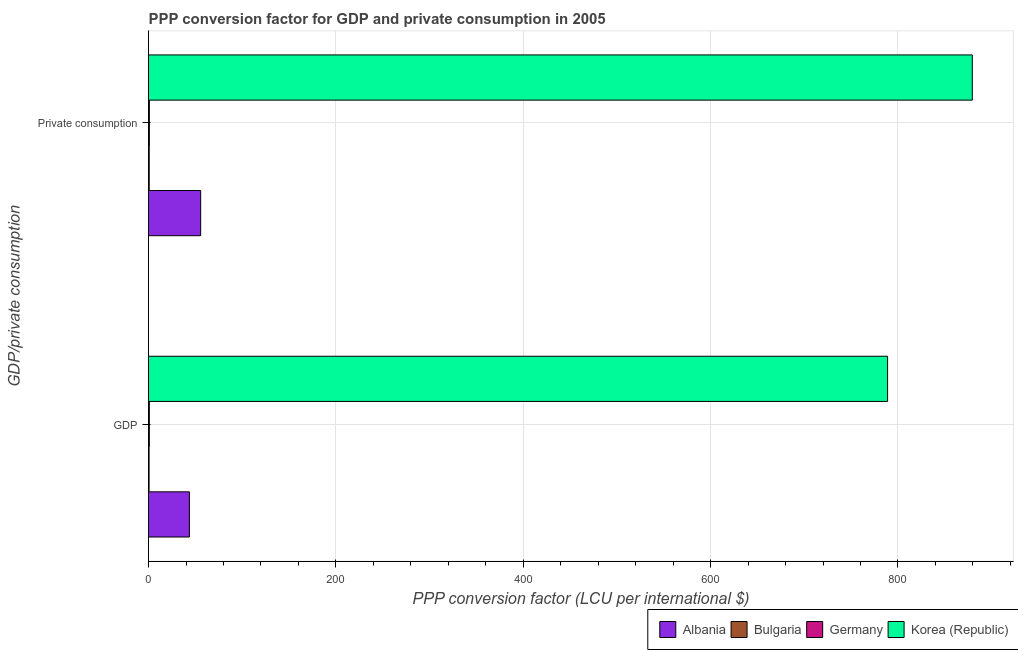How many different coloured bars are there?
Keep it short and to the point. 4. How many bars are there on the 1st tick from the bottom?
Your answer should be compact. 4. What is the label of the 1st group of bars from the top?
Your response must be concise.  Private consumption. What is the ppp conversion factor for private consumption in Germany?
Your response must be concise. 0.9. Across all countries, what is the maximum ppp conversion factor for private consumption?
Your response must be concise. 879.37. Across all countries, what is the minimum ppp conversion factor for private consumption?
Provide a succinct answer. 0.73. In which country was the ppp conversion factor for private consumption maximum?
Give a very brief answer. Korea (Republic). In which country was the ppp conversion factor for private consumption minimum?
Your response must be concise. Bulgaria. What is the total ppp conversion factor for private consumption in the graph?
Provide a succinct answer. 936.65. What is the difference between the ppp conversion factor for private consumption in Korea (Republic) and that in Germany?
Your response must be concise. 878.47. What is the difference between the ppp conversion factor for private consumption in Germany and the ppp conversion factor for gdp in Bulgaria?
Offer a very short reply. 0.3. What is the average ppp conversion factor for private consumption per country?
Offer a terse response. 234.16. What is the difference between the ppp conversion factor for private consumption and ppp conversion factor for gdp in Albania?
Your response must be concise. 12.01. In how many countries, is the ppp conversion factor for private consumption greater than 880 LCU?
Your response must be concise. 0. What is the ratio of the ppp conversion factor for private consumption in Korea (Republic) to that in Bulgaria?
Your answer should be very brief. 1197.36. Is the ppp conversion factor for gdp in Albania less than that in Korea (Republic)?
Offer a terse response. Yes. What does the 2nd bar from the bottom in GDP represents?
Offer a very short reply. Bulgaria. Are all the bars in the graph horizontal?
Make the answer very short. Yes. How many countries are there in the graph?
Your response must be concise. 4. Are the values on the major ticks of X-axis written in scientific E-notation?
Give a very brief answer. No. Does the graph contain any zero values?
Offer a terse response. No. Where does the legend appear in the graph?
Ensure brevity in your answer.  Bottom right. How many legend labels are there?
Make the answer very short. 4. How are the legend labels stacked?
Offer a terse response. Horizontal. What is the title of the graph?
Offer a very short reply. PPP conversion factor for GDP and private consumption in 2005. Does "Singapore" appear as one of the legend labels in the graph?
Offer a terse response. No. What is the label or title of the X-axis?
Provide a succinct answer. PPP conversion factor (LCU per international $). What is the label or title of the Y-axis?
Your response must be concise. GDP/private consumption. What is the PPP conversion factor (LCU per international $) of Albania in GDP?
Provide a succinct answer. 43.64. What is the PPP conversion factor (LCU per international $) of Bulgaria in GDP?
Offer a very short reply. 0.6. What is the PPP conversion factor (LCU per international $) in Germany in GDP?
Provide a succinct answer. 0.87. What is the PPP conversion factor (LCU per international $) of Korea (Republic) in GDP?
Provide a short and direct response. 788.92. What is the PPP conversion factor (LCU per international $) of Albania in  Private consumption?
Ensure brevity in your answer.  55.65. What is the PPP conversion factor (LCU per international $) of Bulgaria in  Private consumption?
Offer a terse response. 0.73. What is the PPP conversion factor (LCU per international $) of Germany in  Private consumption?
Provide a succinct answer. 0.9. What is the PPP conversion factor (LCU per international $) in Korea (Republic) in  Private consumption?
Your response must be concise. 879.37. Across all GDP/private consumption, what is the maximum PPP conversion factor (LCU per international $) in Albania?
Give a very brief answer. 55.65. Across all GDP/private consumption, what is the maximum PPP conversion factor (LCU per international $) of Bulgaria?
Your response must be concise. 0.73. Across all GDP/private consumption, what is the maximum PPP conversion factor (LCU per international $) in Germany?
Provide a succinct answer. 0.9. Across all GDP/private consumption, what is the maximum PPP conversion factor (LCU per international $) of Korea (Republic)?
Provide a short and direct response. 879.37. Across all GDP/private consumption, what is the minimum PPP conversion factor (LCU per international $) in Albania?
Ensure brevity in your answer.  43.64. Across all GDP/private consumption, what is the minimum PPP conversion factor (LCU per international $) of Bulgaria?
Make the answer very short. 0.6. Across all GDP/private consumption, what is the minimum PPP conversion factor (LCU per international $) in Germany?
Ensure brevity in your answer.  0.87. Across all GDP/private consumption, what is the minimum PPP conversion factor (LCU per international $) of Korea (Republic)?
Make the answer very short. 788.92. What is the total PPP conversion factor (LCU per international $) of Albania in the graph?
Keep it short and to the point. 99.29. What is the total PPP conversion factor (LCU per international $) in Bulgaria in the graph?
Your answer should be compact. 1.33. What is the total PPP conversion factor (LCU per international $) in Germany in the graph?
Ensure brevity in your answer.  1.76. What is the total PPP conversion factor (LCU per international $) of Korea (Republic) in the graph?
Your response must be concise. 1668.29. What is the difference between the PPP conversion factor (LCU per international $) of Albania in GDP and that in  Private consumption?
Offer a terse response. -12.01. What is the difference between the PPP conversion factor (LCU per international $) in Bulgaria in GDP and that in  Private consumption?
Offer a very short reply. -0.14. What is the difference between the PPP conversion factor (LCU per international $) in Germany in GDP and that in  Private consumption?
Your response must be concise. -0.03. What is the difference between the PPP conversion factor (LCU per international $) of Korea (Republic) in GDP and that in  Private consumption?
Your response must be concise. -90.45. What is the difference between the PPP conversion factor (LCU per international $) of Albania in GDP and the PPP conversion factor (LCU per international $) of Bulgaria in  Private consumption?
Provide a succinct answer. 42.91. What is the difference between the PPP conversion factor (LCU per international $) in Albania in GDP and the PPP conversion factor (LCU per international $) in Germany in  Private consumption?
Ensure brevity in your answer.  42.74. What is the difference between the PPP conversion factor (LCU per international $) of Albania in GDP and the PPP conversion factor (LCU per international $) of Korea (Republic) in  Private consumption?
Give a very brief answer. -835.73. What is the difference between the PPP conversion factor (LCU per international $) in Bulgaria in GDP and the PPP conversion factor (LCU per international $) in Germany in  Private consumption?
Your response must be concise. -0.3. What is the difference between the PPP conversion factor (LCU per international $) in Bulgaria in GDP and the PPP conversion factor (LCU per international $) in Korea (Republic) in  Private consumption?
Your answer should be compact. -878.77. What is the difference between the PPP conversion factor (LCU per international $) of Germany in GDP and the PPP conversion factor (LCU per international $) of Korea (Republic) in  Private consumption?
Your response must be concise. -878.5. What is the average PPP conversion factor (LCU per international $) of Albania per GDP/private consumption?
Offer a terse response. 49.65. What is the average PPP conversion factor (LCU per international $) in Bulgaria per GDP/private consumption?
Give a very brief answer. 0.67. What is the average PPP conversion factor (LCU per international $) of Germany per GDP/private consumption?
Give a very brief answer. 0.88. What is the average PPP conversion factor (LCU per international $) in Korea (Republic) per GDP/private consumption?
Make the answer very short. 834.14. What is the difference between the PPP conversion factor (LCU per international $) in Albania and PPP conversion factor (LCU per international $) in Bulgaria in GDP?
Offer a terse response. 43.04. What is the difference between the PPP conversion factor (LCU per international $) of Albania and PPP conversion factor (LCU per international $) of Germany in GDP?
Make the answer very short. 42.77. What is the difference between the PPP conversion factor (LCU per international $) of Albania and PPP conversion factor (LCU per international $) of Korea (Republic) in GDP?
Keep it short and to the point. -745.28. What is the difference between the PPP conversion factor (LCU per international $) of Bulgaria and PPP conversion factor (LCU per international $) of Germany in GDP?
Ensure brevity in your answer.  -0.27. What is the difference between the PPP conversion factor (LCU per international $) in Bulgaria and PPP conversion factor (LCU per international $) in Korea (Republic) in GDP?
Give a very brief answer. -788.32. What is the difference between the PPP conversion factor (LCU per international $) of Germany and PPP conversion factor (LCU per international $) of Korea (Republic) in GDP?
Your response must be concise. -788.05. What is the difference between the PPP conversion factor (LCU per international $) of Albania and PPP conversion factor (LCU per international $) of Bulgaria in  Private consumption?
Your answer should be compact. 54.92. What is the difference between the PPP conversion factor (LCU per international $) of Albania and PPP conversion factor (LCU per international $) of Germany in  Private consumption?
Your response must be concise. 54.76. What is the difference between the PPP conversion factor (LCU per international $) of Albania and PPP conversion factor (LCU per international $) of Korea (Republic) in  Private consumption?
Your response must be concise. -823.71. What is the difference between the PPP conversion factor (LCU per international $) of Bulgaria and PPP conversion factor (LCU per international $) of Germany in  Private consumption?
Your answer should be compact. -0.16. What is the difference between the PPP conversion factor (LCU per international $) of Bulgaria and PPP conversion factor (LCU per international $) of Korea (Republic) in  Private consumption?
Provide a short and direct response. -878.63. What is the difference between the PPP conversion factor (LCU per international $) in Germany and PPP conversion factor (LCU per international $) in Korea (Republic) in  Private consumption?
Provide a succinct answer. -878.47. What is the ratio of the PPP conversion factor (LCU per international $) in Albania in GDP to that in  Private consumption?
Give a very brief answer. 0.78. What is the ratio of the PPP conversion factor (LCU per international $) in Bulgaria in GDP to that in  Private consumption?
Provide a succinct answer. 0.82. What is the ratio of the PPP conversion factor (LCU per international $) of Germany in GDP to that in  Private consumption?
Your answer should be very brief. 0.97. What is the ratio of the PPP conversion factor (LCU per international $) in Korea (Republic) in GDP to that in  Private consumption?
Make the answer very short. 0.9. What is the difference between the highest and the second highest PPP conversion factor (LCU per international $) of Albania?
Offer a very short reply. 12.01. What is the difference between the highest and the second highest PPP conversion factor (LCU per international $) of Bulgaria?
Your answer should be very brief. 0.14. What is the difference between the highest and the second highest PPP conversion factor (LCU per international $) of Germany?
Make the answer very short. 0.03. What is the difference between the highest and the second highest PPP conversion factor (LCU per international $) in Korea (Republic)?
Offer a terse response. 90.45. What is the difference between the highest and the lowest PPP conversion factor (LCU per international $) of Albania?
Keep it short and to the point. 12.01. What is the difference between the highest and the lowest PPP conversion factor (LCU per international $) in Bulgaria?
Your response must be concise. 0.14. What is the difference between the highest and the lowest PPP conversion factor (LCU per international $) in Korea (Republic)?
Offer a very short reply. 90.45. 